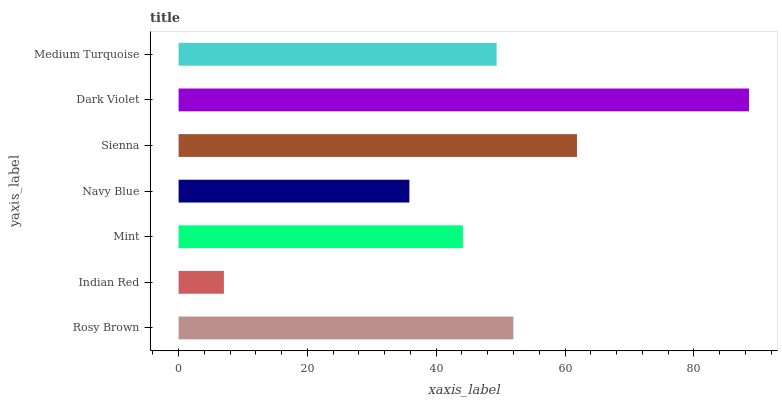Is Indian Red the minimum?
Answer yes or no. Yes. Is Dark Violet the maximum?
Answer yes or no. Yes. Is Mint the minimum?
Answer yes or no. No. Is Mint the maximum?
Answer yes or no. No. Is Mint greater than Indian Red?
Answer yes or no. Yes. Is Indian Red less than Mint?
Answer yes or no. Yes. Is Indian Red greater than Mint?
Answer yes or no. No. Is Mint less than Indian Red?
Answer yes or no. No. Is Medium Turquoise the high median?
Answer yes or no. Yes. Is Medium Turquoise the low median?
Answer yes or no. Yes. Is Navy Blue the high median?
Answer yes or no. No. Is Sienna the low median?
Answer yes or no. No. 